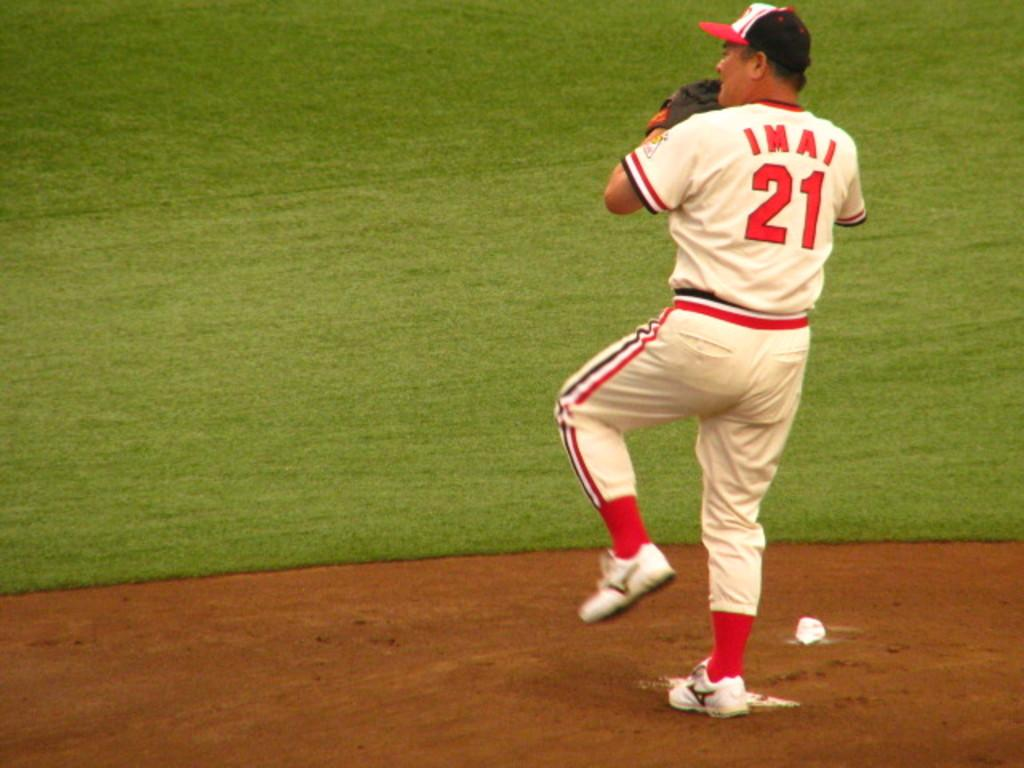<image>
Relay a brief, clear account of the picture shown. baseball pitcher getting ready to throw the ball, his name is IMAI # 21. 